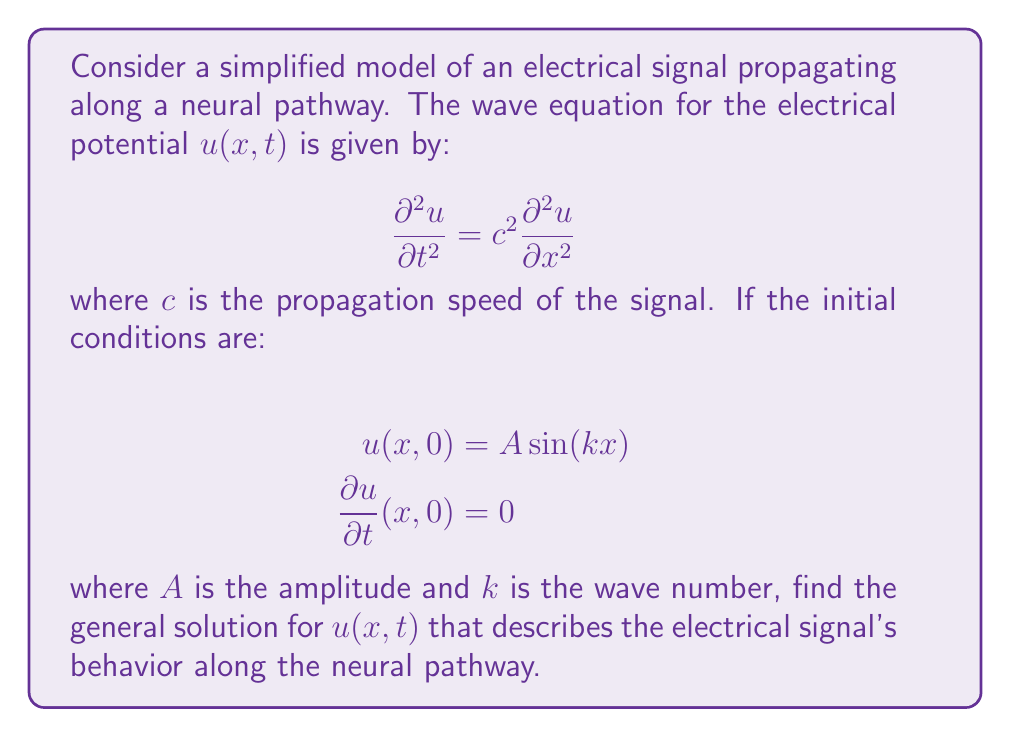Show me your answer to this math problem. To solve this wave equation with the given initial conditions, we'll follow these steps:

1) The general solution for the wave equation is of the form:

   $$u(x,t) = F(x-ct) + G(x+ct)$$

   where $F$ and $G$ are arbitrary functions.

2) Given the initial condition $u(x,0) = A \sin(kx)$, we can write:

   $$F(x) + G(x) = A \sin(kx)$$

3) The second initial condition $\frac{\partial u}{\partial t}(x,0) = 0$ implies:

   $$-cF'(x) + cG'(x) = 0$$

   Therefore, $F'(x) = G'(x)$

4) Integrating this, we get:

   $$F(x) = G(x) + constant$$

5) Substituting this into the equation from step 2:

   $$2F(x) + constant = A \sin(kx)$$

   $$F(x) = \frac{A}{2} \sin(kx) - \frac{constant}{2}$$

6) We can choose the constant to be zero for simplicity. Thus:

   $$F(x) = G(x) = \frac{A}{2} \sin(kx)$$

7) Substituting these functions into the general solution:

   $$u(x,t) = \frac{A}{2} \sin(k(x-ct)) + \frac{A}{2} \sin(k(x+ct))$$

8) Using the trigonometric identity for the sum of sines:

   $$u(x,t) = A \sin(kx) \cos(kct)$$

This solution represents a standing wave, which is consistent with the initial conditions of a sinusoidal spatial distribution with no initial velocity.
Answer: $u(x,t) = A \sin(kx) \cos(kct)$ 